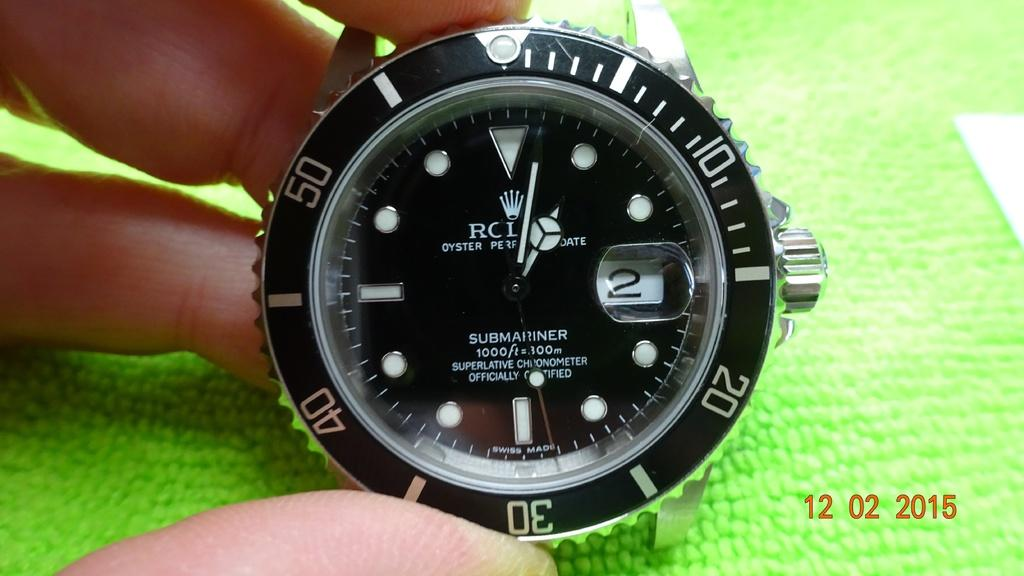<image>
Describe the image concisely. A watch says "SUBMARINER" on the black face. 